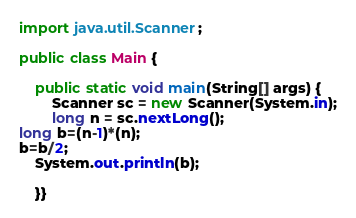<code> <loc_0><loc_0><loc_500><loc_500><_Java_>import java.util.Scanner;

public class Main {

	public static void main(String[] args) {
		Scanner sc = new Scanner(System.in);
		long n = sc.nextLong();
long b=(n-1)*(n);
b=b/2;
	System.out.println(b);

	}}
</code> 